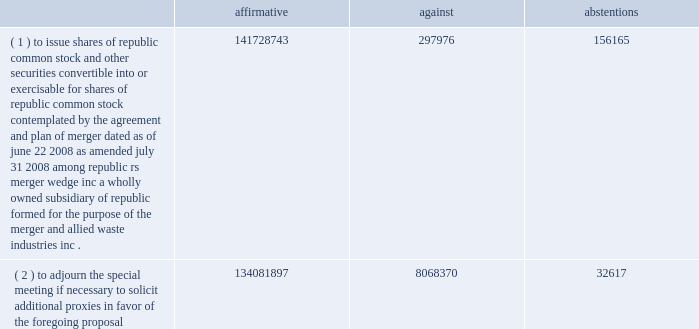Connection with this matter could have a material adverse impact on our consolidated cash flows and results of operations .
Item 4 .
Submission of matters to a vote of security holders on november 14 , 2008 , our stockholders voted to approve our merger with allied waste industries , inc .
At a special meeting held for that purpose .
Results of the voting at that meeting are as follows: .
( 1 ) to issue shares of republic common stock and other securities convertible into or exercisable for shares of republic common stock , contemplated by the agreement and plan of merger , dated as of june 22 , 2008 , as amended july 31 , 2008 , among republic , rs merger wedge , inc , a wholly owned subsidiary of republic , formed for the purpose of the merger , and allied waste industries , inc .
141728743 297976 156165 ( 2 ) to adjourn the special meeting , if necessary , to solicit additional proxies in favor of the foregoing proposal .
134081897 8068370 32617 %%transmsg*** transmitting job : p14076 pcn : 035000000 ***%%pcmsg|33 |00022|yes|no|02/28/2009 17:08|0|0|page is valid , no graphics -- color : d| .
What the total number of votes to issue shares of republic common stock and other securities convertible? 
Rationale: the total number of votes is the sum of the votes 142182884
Computations: ((141728743 + 297976) + 156165)
Answer: 142182884.0. 